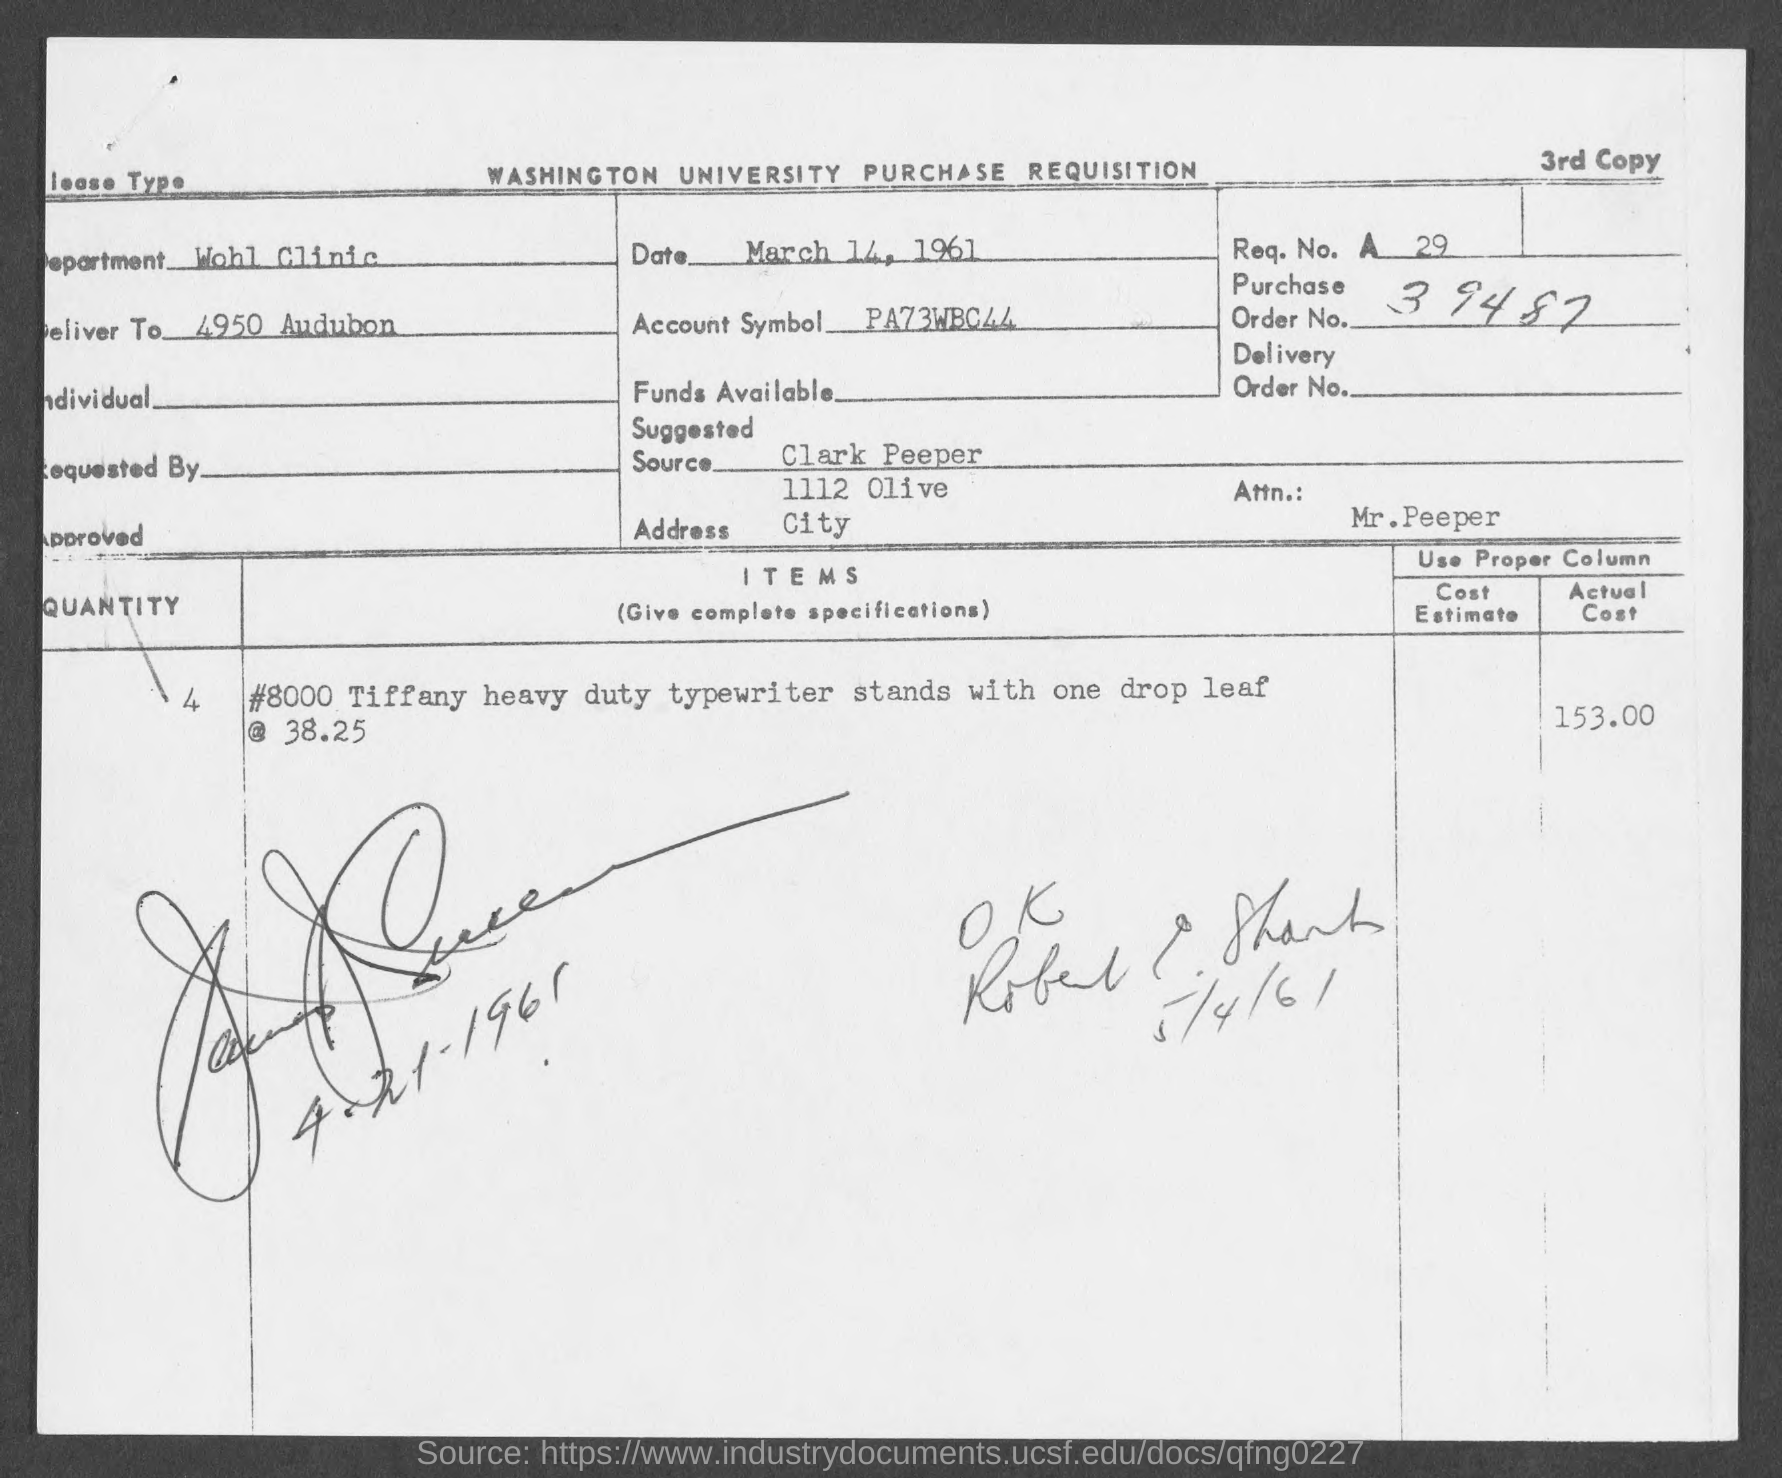Draw attention to some important aspects in this diagram. The account symbol PA73WBC44 represents an account number. What is the purchase order number? 39487... 